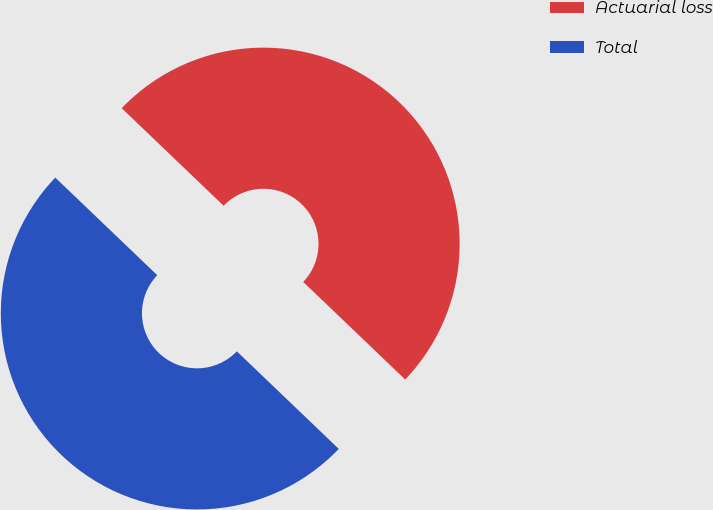Convert chart. <chart><loc_0><loc_0><loc_500><loc_500><pie_chart><fcel>Actuarial loss<fcel>Total<nl><fcel>50.0%<fcel>50.0%<nl></chart> 